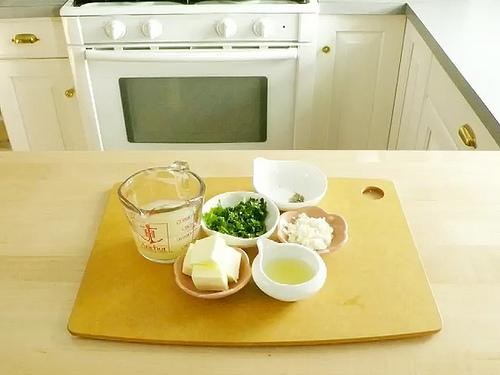Which one of these processes produced the spread here? Please explain your reasoning. food prep. The other options don't apply to the preparation of ingredients. 